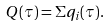<formula> <loc_0><loc_0><loc_500><loc_500>Q ( \tau ) = \Sigma q _ { i } ( \tau ) .</formula> 